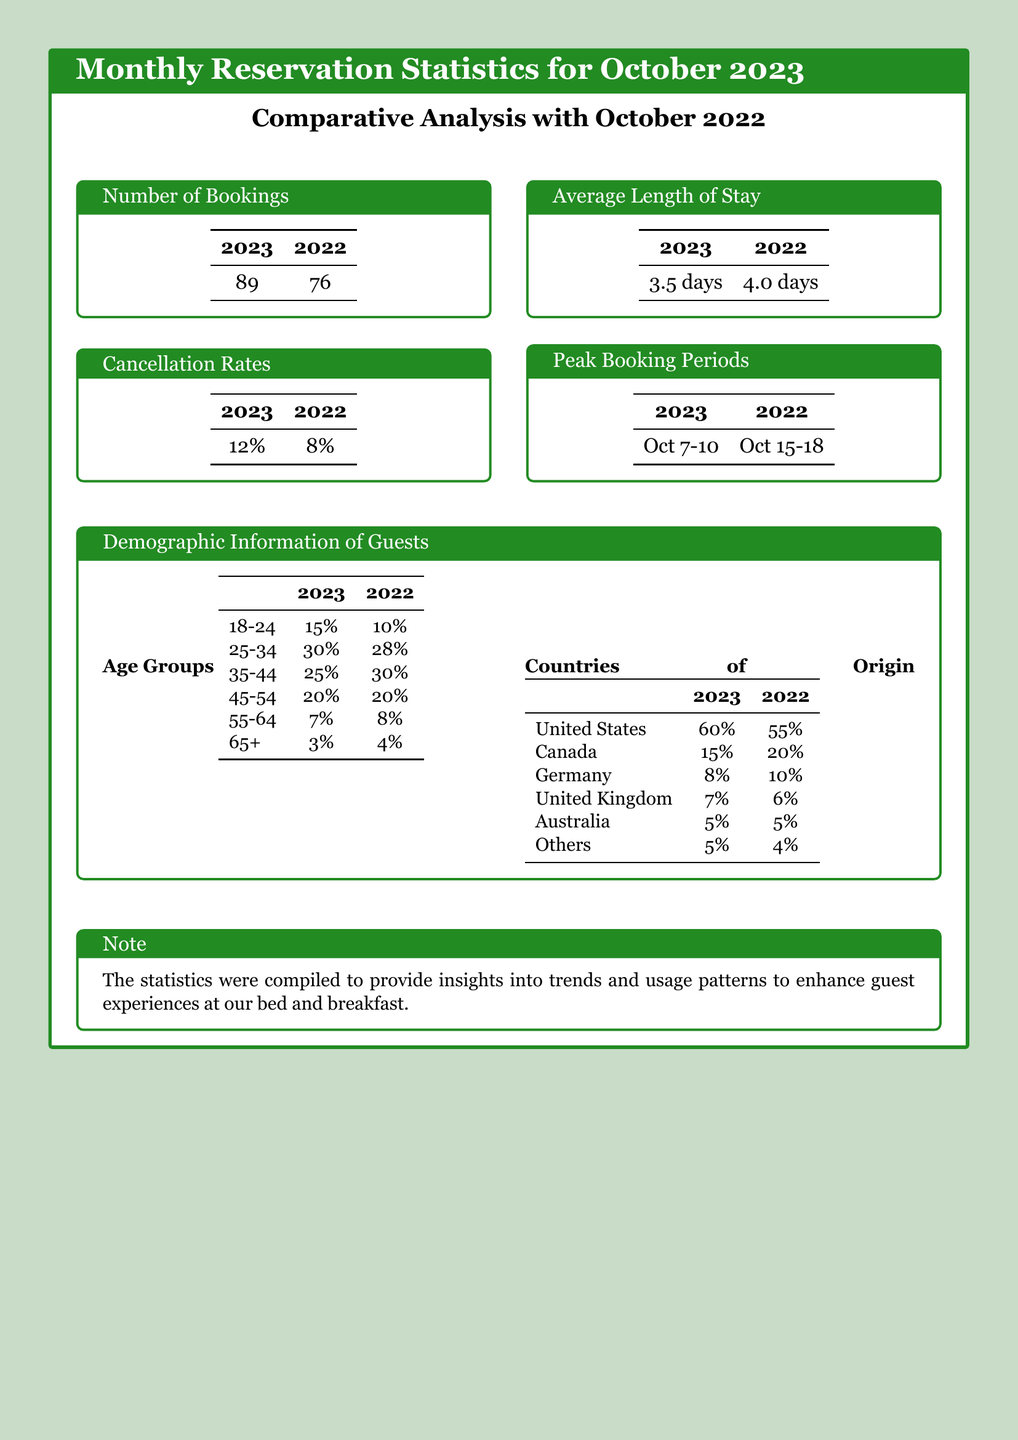what was the number of bookings in October 2023? The number of bookings in October 2023 is specified in the document, which states 89 bookings.
Answer: 89 what was the average length of stay in October 2022? The document indicates that the average length of stay for October 2022 was 4.0 days.
Answer: 4.0 days what is the cancellation rate for October 2023? The cancellation rate for October 2023 is provided as 12% in the document.
Answer: 12% what are the peak booking periods for 2023? The document lists the peak booking periods for October 2023, which is from October 7-10.
Answer: Oct 7-10 which age group saw the largest percentage increase from 2022 to 2023? The increase in the age group 18-24 from 10% in 2022 to 15% in 2023 shows the largest change in percentage.
Answer: 18-24 how many guests came from the United States in 2023? The document indicates that 60% of guests in 2023 were from the United States.
Answer: 60% what percentage of guests aged 65 and older was recorded in 2022? The document states that the percentage of guests aged 65 and older in 2022 was 4%.
Answer: 4% how many more bookings were recorded in October 2023 compared to 2022? The document specifies 89 bookings in 2023 and 76 in 2022, thus an increase of 13 bookings.
Answer: 13 what is the total percentage of guests from Canada in 2023? The total percentage of guests from Canada in 2023 according to the document is 15%.
Answer: 15% 